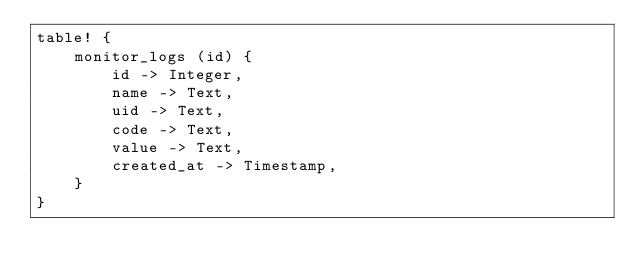Convert code to text. <code><loc_0><loc_0><loc_500><loc_500><_Rust_>table! {
    monitor_logs (id) {
        id -> Integer,
        name -> Text,
        uid -> Text,
        code -> Text,
        value -> Text,
        created_at -> Timestamp,
    }
}
</code> 